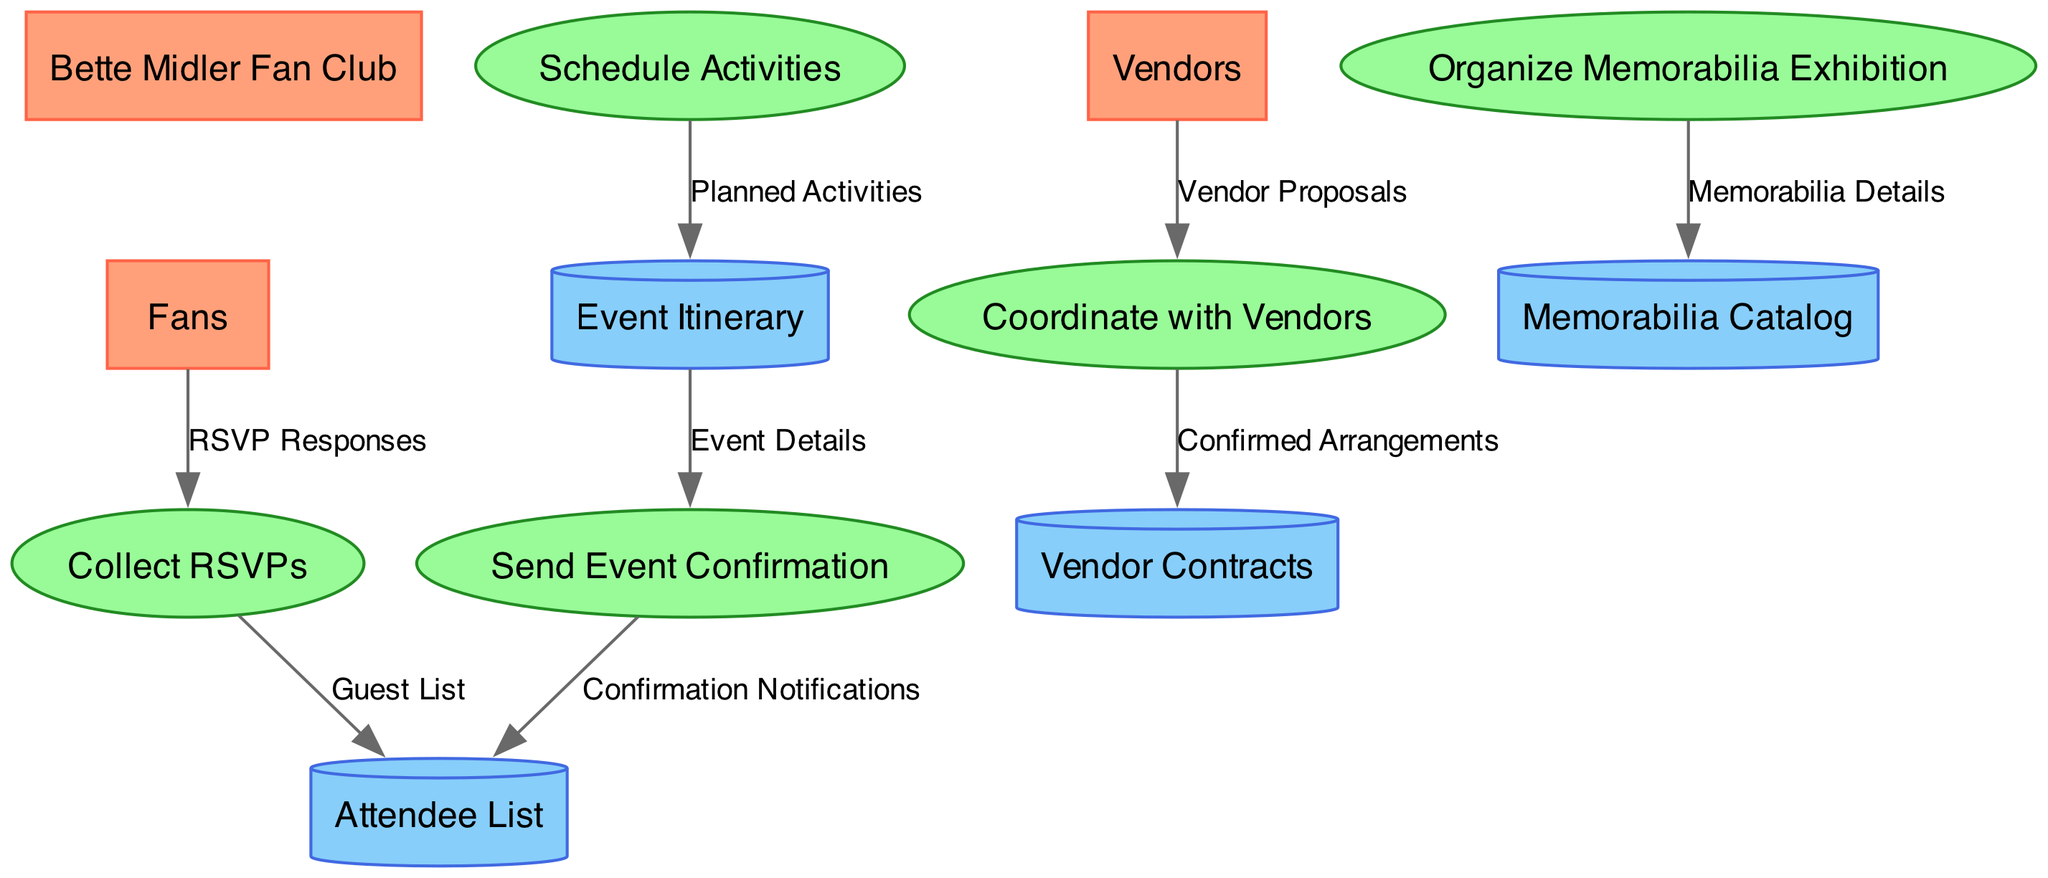What is the external entity that interacts with the process "Collect RSVPs"? The external entity that interacts with "Collect RSVPs" is "Fans." They provide the RSVP responses that the process gathers to know who will attend the event.
Answer: Fans How many processes are listed in the diagram? There are five processes shown in the diagram, which include tasks like Collect RSVPs and Schedule Activities. Each process contributes to organizing the event.
Answer: 5 What data store holds information about the confirmed attendees? The data store that holds information about confirmed attendees is "Attendee List." It compiles the responses from the RSVP collection to list who will attend.
Answer: Attendee List Which process sends final event details to attendees? The process that sends final event details to attendees is "Send Event Confirmation." It communicates important information regarding the event schedule to those who confirmed their attendance.
Answer: Send Event Confirmation What is the data flow from "Vendors" to the process that manages supplies? The data flow from "Vendors" to manage supplies is labeled "Vendor Proposals." This flow includes all the proposals vendors submit for the needed supplies and services for the event.
Answer: Vendor Proposals What is the relationship between "Schedule Activities" and "Event Itinerary"? The relationship is that "Schedule Activities" produces "Planned Activities," which then feed into the "Event Itinerary." This outlines all scheduled activities during the event.
Answer: Planned Activities How many external entities are involved in the diagram? The diagram includes three external entities, which are the Bette Midler Fan Club, Fans, and Vendors. Each entity plays a role in contributing to the event's planning or participation.
Answer: 3 What does the "Memorabilia Catalog" store? The "Memorabilia Catalog" stores the details of all memorabilia items available for display at the event, including their descriptions and conditions.
Answer: Memorabilia Details Which entity receives confirmation notifications? The entity that receives confirmation notifications is the "Attendee List." This ensures that all attendees are informed of their participation in the event after confirmation.
Answer: Attendee List 